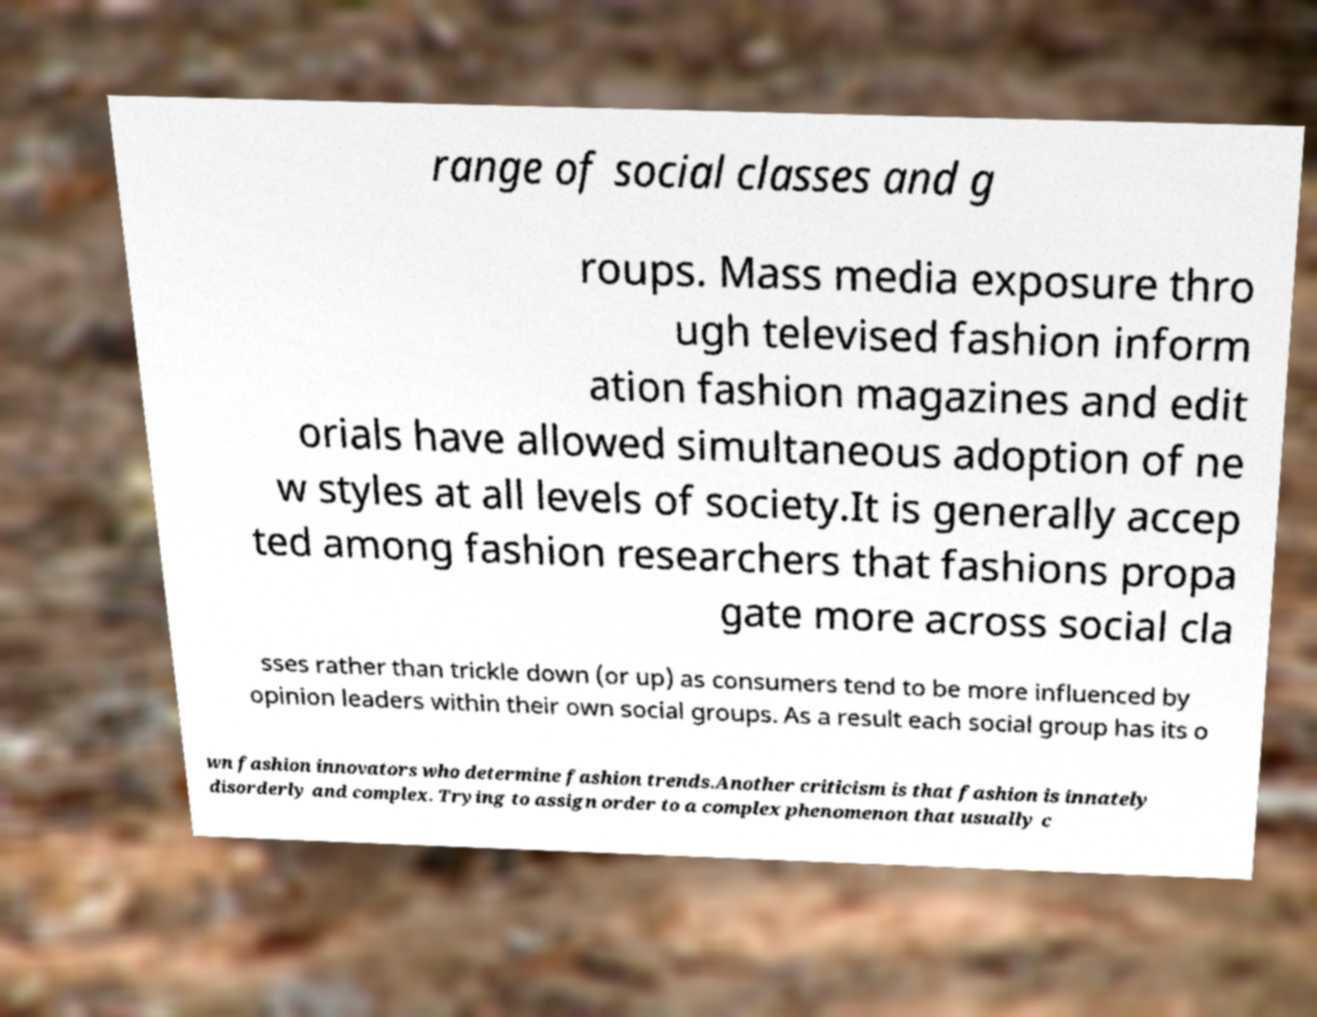For documentation purposes, I need the text within this image transcribed. Could you provide that? range of social classes and g roups. Mass media exposure thro ugh televised fashion inform ation fashion magazines and edit orials have allowed simultaneous adoption of ne w styles at all levels of society.It is generally accep ted among fashion researchers that fashions propa gate more across social cla sses rather than trickle down (or up) as consumers tend to be more influenced by opinion leaders within their own social groups. As a result each social group has its o wn fashion innovators who determine fashion trends.Another criticism is that fashion is innately disorderly and complex. Trying to assign order to a complex phenomenon that usually c 